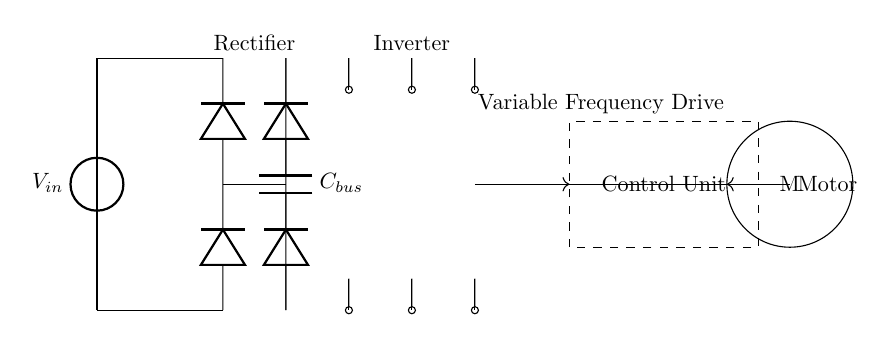What type of circuit is represented here? This circuit is a variable frequency drive circuit, which is specifically used to control motor speed. The presence of a rectifier, DC bus, inverter, and control unit indicates it is designed for driving motors with variable frequency and voltage.
Answer: variable frequency drive What is the role of the rectifier in this circuit? The rectifier converts the alternating current from the power source into direct current for further processing. It consists of diodes that allow current to pass in one direction, effectively providing a DC voltage to the circuit.
Answer: convert AC to DC How many main components are visible in the circuit? The circuit diagram shows five main components: the power source, rectifier, DC bus, inverter, and control unit, along with the motor. Therefore, the total count is five.
Answer: five Which component stores energy in this circuit? The capacitor labeled C bus is responsible for storing energy in the circuit. Capacitors store electrical energy when charged and can release it when needed to maintain a steady voltage level.
Answer: C bus What is the function of the control unit in this variable frequency drive circuit? The control unit regulates the output frequency and voltage supplied to the motor, which directly affects its speed and torque. By adjusting these parameters, the control unit allows for precise motor control and improved efficiency.
Answer: regulate motor speed Which components are involved in producing the output to the motor? The inverter is the key component responsible for producing the output to the motor by converting the DC voltage back into an alternating current with a variable frequency, while the control unit modifies this to set the speed.
Answer: inverter, control unit 